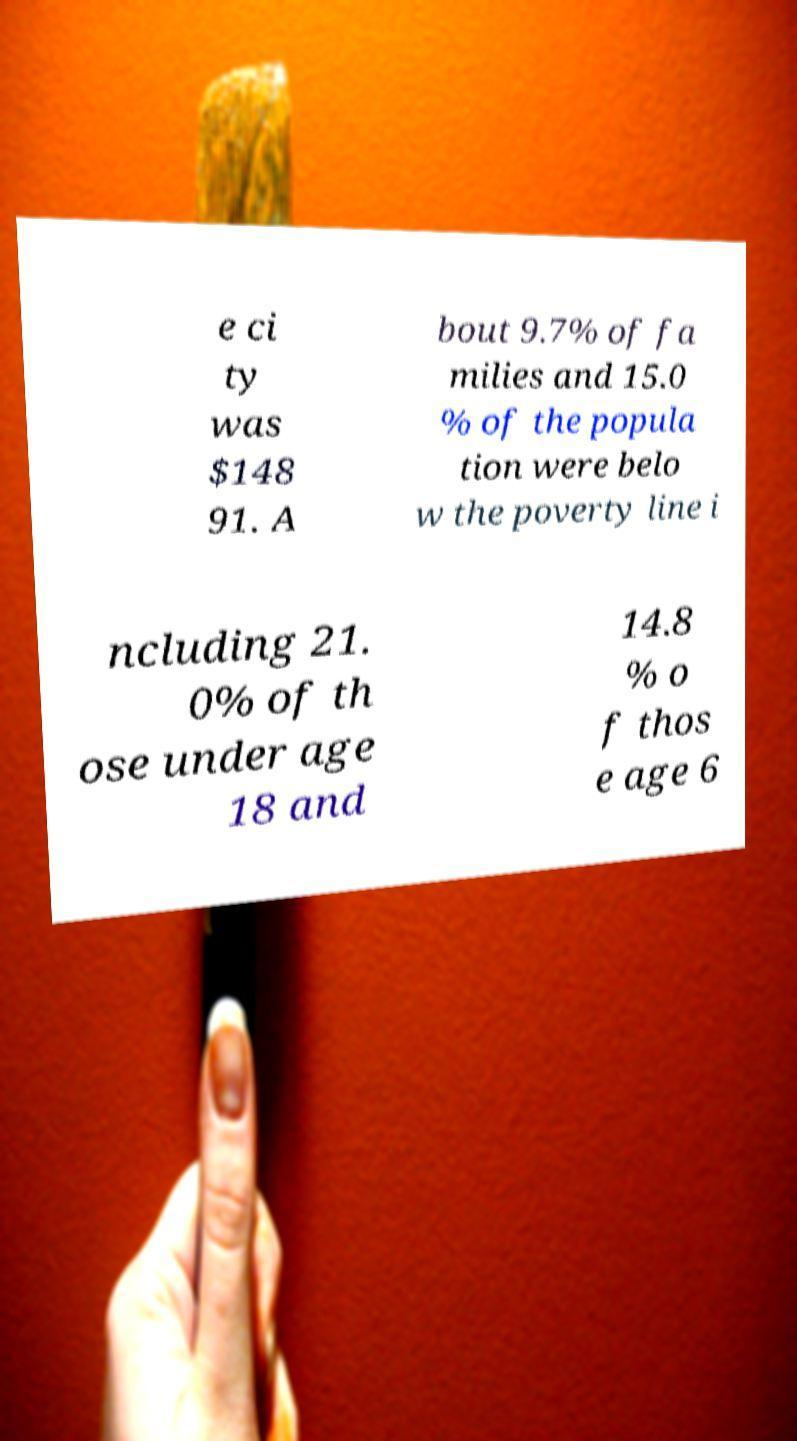Please identify and transcribe the text found in this image. e ci ty was $148 91. A bout 9.7% of fa milies and 15.0 % of the popula tion were belo w the poverty line i ncluding 21. 0% of th ose under age 18 and 14.8 % o f thos e age 6 